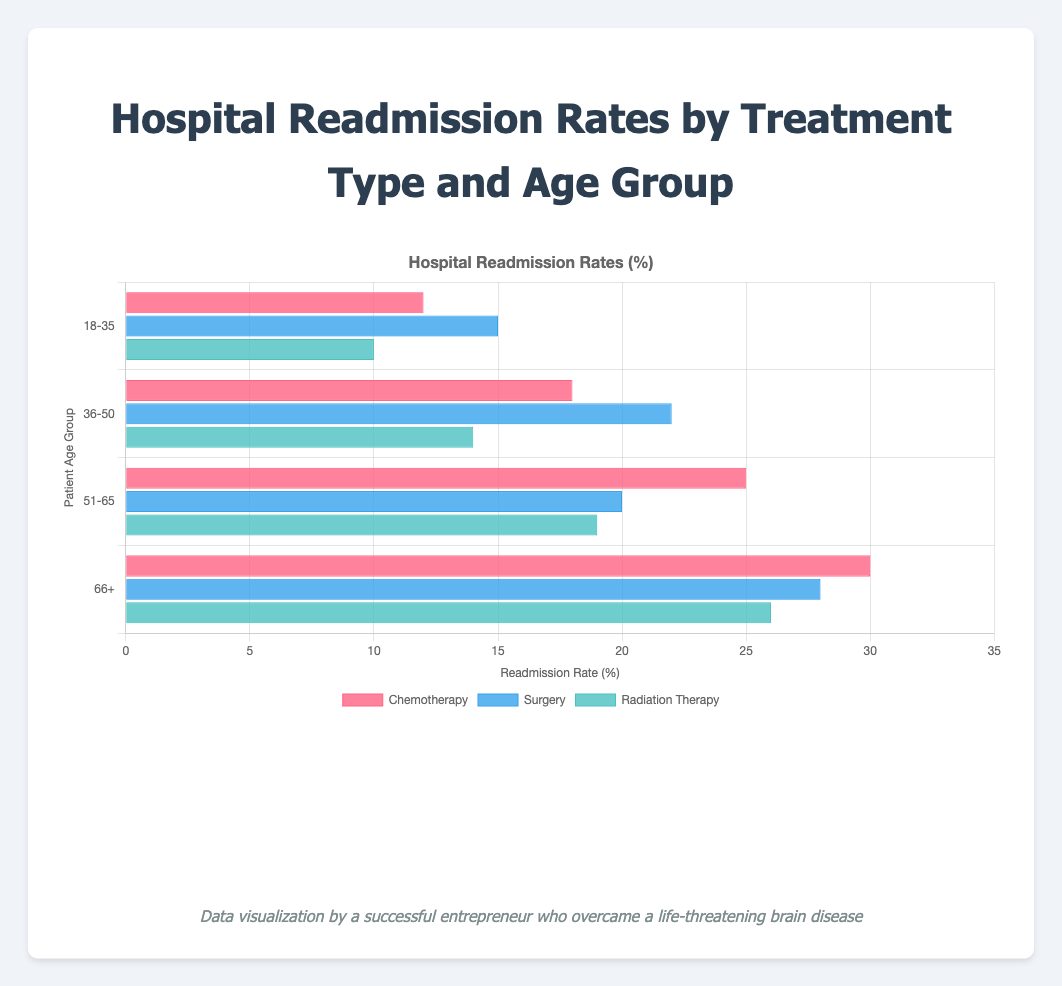Which age group has the highest hospital readmission rate for surgery? Look at the bars corresponding to "Surgery" for each age group and compare their heights. The bar for the 36-50 age group is the highest at 22%.
Answer: 36-50 Which treatment type has the lowest readmission rate in the 18-35 age group? Look at the three bars for the 18-35 age group and compare their heights. The bar for "Radiation Therapy" is the shortest at 10%.
Answer: Radiation Therapy What's the difference in readmission rates between chemotherapy and radiation therapy for the 51-65 age group? Identify the bars for "Chemotherapy" and "Radiation Therapy" in the 51-65 age group, which are 25% and 19% respectively. Subtract the smaller value from the larger value: 25 - 19 = 6.
Answer: 6% How does the readmission rate for chemotherapy in the 66+ age group compare to surgery in the same age group? Compare the heights of the bars for "Chemotherapy" and "Surgery" in the 66+ age group. Chemotherapy has a rate of 30%, while surgery has a rate of 28%. Chemotherapy's rate is higher.
Answer: Chemotherapy is higher What is the average readmission rate for radiation therapy across all age groups? The readmission rates for radiation therapy for each age group are 10%, 14%, 19%, and 26%. Sum these and divide them by 4: (10 + 14 + 19 + 26) / 4 = 17.25%.
Answer: 17.25% Which two treatments have the closest readmission rates in the 66+ age group? Compare the bars for the 66+ age group: Chemotherapy (30%), Surgery (28%), and Radiation Therapy (26%). Surgery and Radiation Therapy have the closest rates with a difference of 2%.
Answer: Surgery and Radiation Therapy What's the total readmission rate for all treatments in the 36-50 age group combined? Add the readmission rates for Chemotherapy (18%), Surgery (22%), and Radiation Therapy (14%) in the 36-50 age group: 18 + 22 + 14 = 54%.
Answer: 54% Out of all treatment types, which one has the largest range of readmission rates across the age groups? Calculate the range for each treatment by subtracting the smallest rate from the largest rate:
- Chemotherapy: 30 - 12 = 18
- Surgery: 28 - 15 = 13
- Radiation Therapy: 26 - 10 = 16
Chemotherapy has the largest range.
Answer: Chemotherapy Which treatment type consistently shows a decreasing readmission rate with increasing age group? Compare the readmission rates for each age group from younger to older:
- Chemotherapy: 12, 18, 25, 30 (Increasing)
- Surgery: 15, 22, 20, 28 (Not consistent)
- Radiation Therapy: 10, 14, 19, 26 (Increasing)
None show a consistent decrease.
Answer: None 